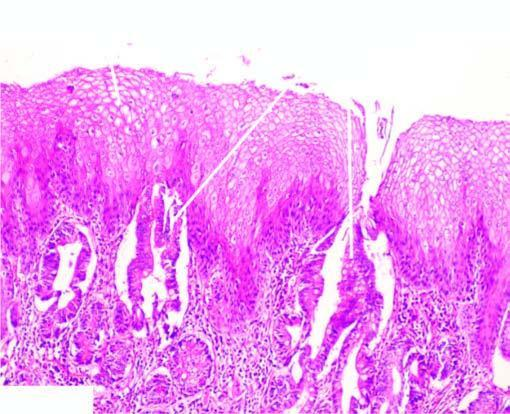does adp undergo metaplastic change to columnar epithelium of intestinal type?
Answer the question using a single word or phrase. No 